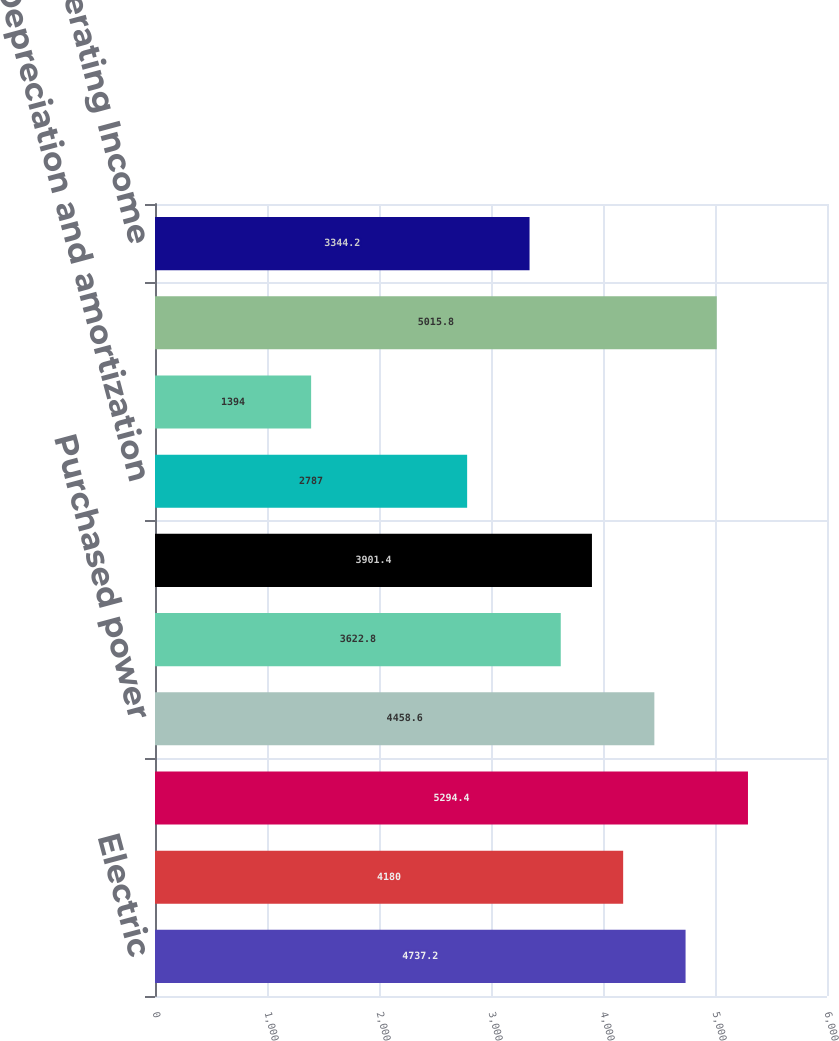Convert chart to OTSL. <chart><loc_0><loc_0><loc_500><loc_500><bar_chart><fcel>Electric<fcel>Gas<fcel>Total operating revenues<fcel>Purchased power<fcel>Gas purchased for resale<fcel>Other operations and<fcel>Depreciation and amortization<fcel>Taxes other than income taxes<fcel>Total operating expenses<fcel>Operating Income<nl><fcel>4737.2<fcel>4180<fcel>5294.4<fcel>4458.6<fcel>3622.8<fcel>3901.4<fcel>2787<fcel>1394<fcel>5015.8<fcel>3344.2<nl></chart> 